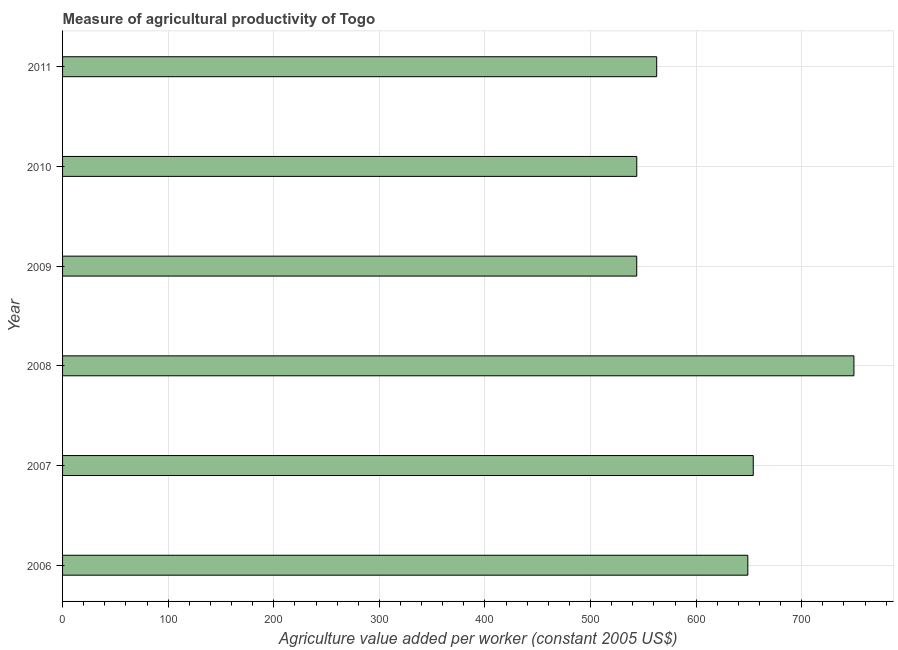Does the graph contain grids?
Offer a very short reply. Yes. What is the title of the graph?
Provide a succinct answer. Measure of agricultural productivity of Togo. What is the label or title of the X-axis?
Ensure brevity in your answer.  Agriculture value added per worker (constant 2005 US$). What is the label or title of the Y-axis?
Ensure brevity in your answer.  Year. What is the agriculture value added per worker in 2007?
Offer a very short reply. 654.09. Across all years, what is the maximum agriculture value added per worker?
Ensure brevity in your answer.  749.41. Across all years, what is the minimum agriculture value added per worker?
Your answer should be compact. 543.73. In which year was the agriculture value added per worker minimum?
Keep it short and to the point. 2009. What is the sum of the agriculture value added per worker?
Offer a terse response. 3702.58. What is the difference between the agriculture value added per worker in 2009 and 2010?
Provide a short and direct response. -0.06. What is the average agriculture value added per worker per year?
Provide a short and direct response. 617.1. What is the median agriculture value added per worker?
Ensure brevity in your answer.  605.79. What is the ratio of the agriculture value added per worker in 2009 to that in 2010?
Offer a very short reply. 1. Is the agriculture value added per worker in 2006 less than that in 2009?
Make the answer very short. No. Is the difference between the agriculture value added per worker in 2006 and 2007 greater than the difference between any two years?
Provide a succinct answer. No. What is the difference between the highest and the second highest agriculture value added per worker?
Keep it short and to the point. 95.32. What is the difference between the highest and the lowest agriculture value added per worker?
Your response must be concise. 205.68. In how many years, is the agriculture value added per worker greater than the average agriculture value added per worker taken over all years?
Offer a terse response. 3. How many bars are there?
Your answer should be compact. 6. Are all the bars in the graph horizontal?
Provide a succinct answer. Yes. What is the Agriculture value added per worker (constant 2005 US$) of 2006?
Provide a succinct answer. 648.93. What is the Agriculture value added per worker (constant 2005 US$) of 2007?
Give a very brief answer. 654.09. What is the Agriculture value added per worker (constant 2005 US$) in 2008?
Ensure brevity in your answer.  749.41. What is the Agriculture value added per worker (constant 2005 US$) in 2009?
Offer a very short reply. 543.73. What is the Agriculture value added per worker (constant 2005 US$) in 2010?
Give a very brief answer. 543.78. What is the Agriculture value added per worker (constant 2005 US$) of 2011?
Provide a succinct answer. 562.64. What is the difference between the Agriculture value added per worker (constant 2005 US$) in 2006 and 2007?
Keep it short and to the point. -5.15. What is the difference between the Agriculture value added per worker (constant 2005 US$) in 2006 and 2008?
Make the answer very short. -100.47. What is the difference between the Agriculture value added per worker (constant 2005 US$) in 2006 and 2009?
Provide a succinct answer. 105.21. What is the difference between the Agriculture value added per worker (constant 2005 US$) in 2006 and 2010?
Make the answer very short. 105.15. What is the difference between the Agriculture value added per worker (constant 2005 US$) in 2006 and 2011?
Ensure brevity in your answer.  86.29. What is the difference between the Agriculture value added per worker (constant 2005 US$) in 2007 and 2008?
Your answer should be compact. -95.32. What is the difference between the Agriculture value added per worker (constant 2005 US$) in 2007 and 2009?
Provide a short and direct response. 110.36. What is the difference between the Agriculture value added per worker (constant 2005 US$) in 2007 and 2010?
Your response must be concise. 110.3. What is the difference between the Agriculture value added per worker (constant 2005 US$) in 2007 and 2011?
Make the answer very short. 91.44. What is the difference between the Agriculture value added per worker (constant 2005 US$) in 2008 and 2009?
Offer a very short reply. 205.68. What is the difference between the Agriculture value added per worker (constant 2005 US$) in 2008 and 2010?
Give a very brief answer. 205.63. What is the difference between the Agriculture value added per worker (constant 2005 US$) in 2008 and 2011?
Offer a terse response. 186.76. What is the difference between the Agriculture value added per worker (constant 2005 US$) in 2009 and 2010?
Give a very brief answer. -0.05. What is the difference between the Agriculture value added per worker (constant 2005 US$) in 2009 and 2011?
Your answer should be compact. -18.92. What is the difference between the Agriculture value added per worker (constant 2005 US$) in 2010 and 2011?
Your answer should be very brief. -18.86. What is the ratio of the Agriculture value added per worker (constant 2005 US$) in 2006 to that in 2008?
Your response must be concise. 0.87. What is the ratio of the Agriculture value added per worker (constant 2005 US$) in 2006 to that in 2009?
Offer a terse response. 1.19. What is the ratio of the Agriculture value added per worker (constant 2005 US$) in 2006 to that in 2010?
Keep it short and to the point. 1.19. What is the ratio of the Agriculture value added per worker (constant 2005 US$) in 2006 to that in 2011?
Provide a succinct answer. 1.15. What is the ratio of the Agriculture value added per worker (constant 2005 US$) in 2007 to that in 2008?
Your answer should be very brief. 0.87. What is the ratio of the Agriculture value added per worker (constant 2005 US$) in 2007 to that in 2009?
Ensure brevity in your answer.  1.2. What is the ratio of the Agriculture value added per worker (constant 2005 US$) in 2007 to that in 2010?
Your response must be concise. 1.2. What is the ratio of the Agriculture value added per worker (constant 2005 US$) in 2007 to that in 2011?
Provide a succinct answer. 1.16. What is the ratio of the Agriculture value added per worker (constant 2005 US$) in 2008 to that in 2009?
Your answer should be compact. 1.38. What is the ratio of the Agriculture value added per worker (constant 2005 US$) in 2008 to that in 2010?
Ensure brevity in your answer.  1.38. What is the ratio of the Agriculture value added per worker (constant 2005 US$) in 2008 to that in 2011?
Ensure brevity in your answer.  1.33. What is the ratio of the Agriculture value added per worker (constant 2005 US$) in 2010 to that in 2011?
Your answer should be compact. 0.97. 